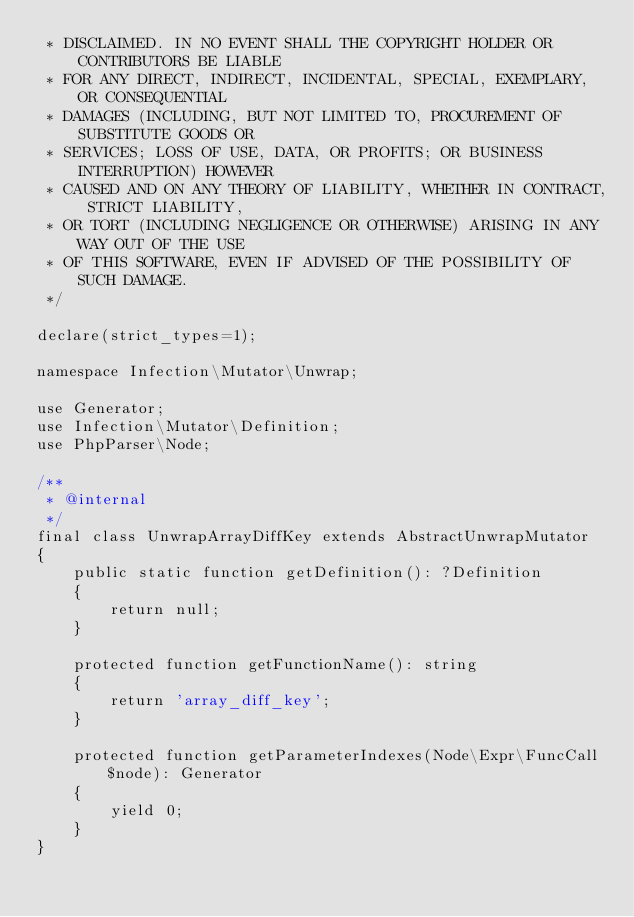<code> <loc_0><loc_0><loc_500><loc_500><_PHP_> * DISCLAIMED. IN NO EVENT SHALL THE COPYRIGHT HOLDER OR CONTRIBUTORS BE LIABLE
 * FOR ANY DIRECT, INDIRECT, INCIDENTAL, SPECIAL, EXEMPLARY, OR CONSEQUENTIAL
 * DAMAGES (INCLUDING, BUT NOT LIMITED TO, PROCUREMENT OF SUBSTITUTE GOODS OR
 * SERVICES; LOSS OF USE, DATA, OR PROFITS; OR BUSINESS INTERRUPTION) HOWEVER
 * CAUSED AND ON ANY THEORY OF LIABILITY, WHETHER IN CONTRACT, STRICT LIABILITY,
 * OR TORT (INCLUDING NEGLIGENCE OR OTHERWISE) ARISING IN ANY WAY OUT OF THE USE
 * OF THIS SOFTWARE, EVEN IF ADVISED OF THE POSSIBILITY OF SUCH DAMAGE.
 */

declare(strict_types=1);

namespace Infection\Mutator\Unwrap;

use Generator;
use Infection\Mutator\Definition;
use PhpParser\Node;

/**
 * @internal
 */
final class UnwrapArrayDiffKey extends AbstractUnwrapMutator
{
    public static function getDefinition(): ?Definition
    {
        return null;
    }

    protected function getFunctionName(): string
    {
        return 'array_diff_key';
    }

    protected function getParameterIndexes(Node\Expr\FuncCall $node): Generator
    {
        yield 0;
    }
}
</code> 